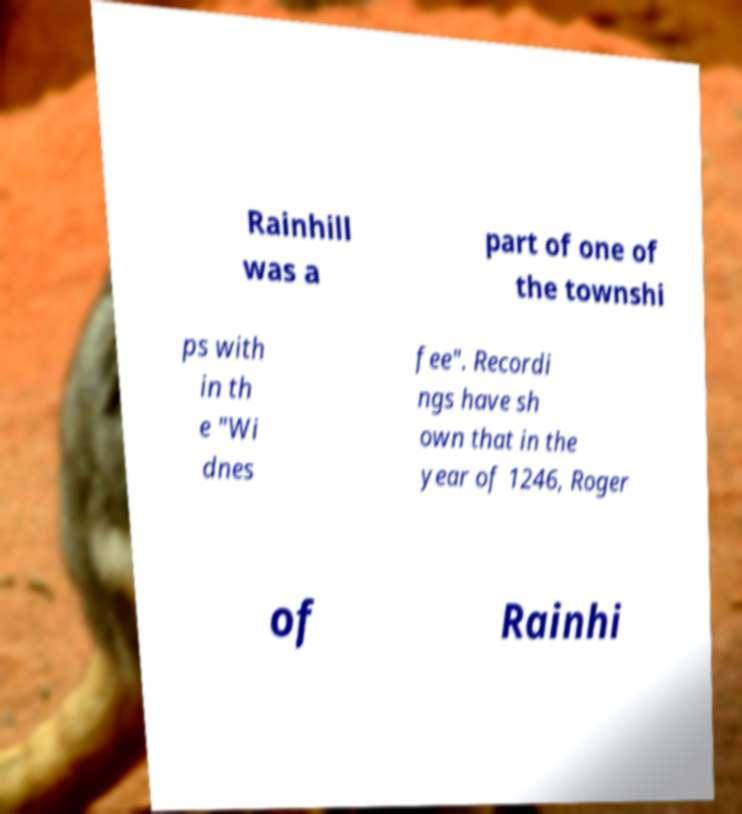For documentation purposes, I need the text within this image transcribed. Could you provide that? Rainhill was a part of one of the townshi ps with in th e "Wi dnes fee". Recordi ngs have sh own that in the year of 1246, Roger of Rainhi 